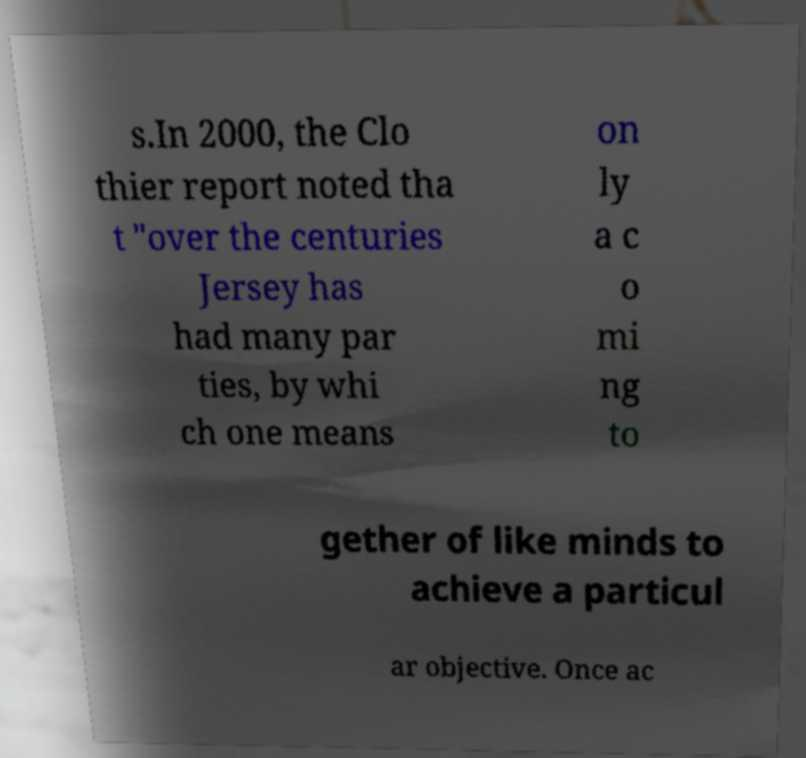For documentation purposes, I need the text within this image transcribed. Could you provide that? s.In 2000, the Clo thier report noted tha t "over the centuries Jersey has had many par ties, by whi ch one means on ly a c o mi ng to gether of like minds to achieve a particul ar objective. Once ac 